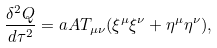<formula> <loc_0><loc_0><loc_500><loc_500>\frac { \delta ^ { 2 } Q } { d \tau ^ { 2 } } = a A T _ { \mu \nu } ( \xi ^ { \mu } \xi ^ { \nu } + \eta ^ { \mu } \eta ^ { \nu } ) ,</formula> 